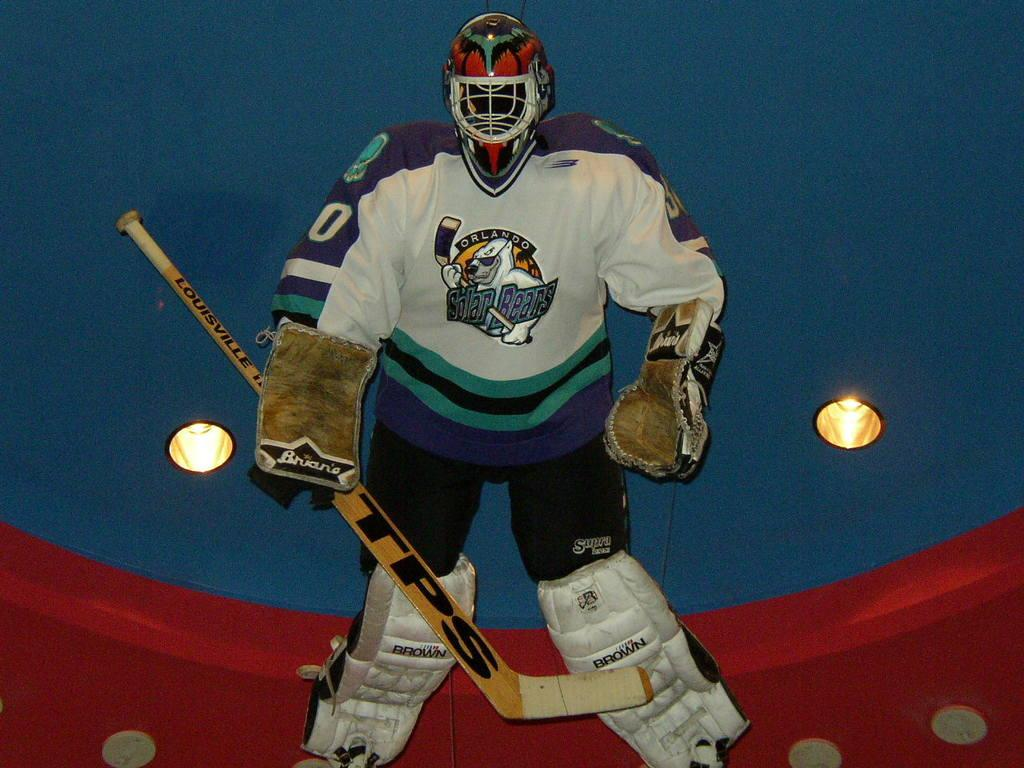What type of protective gear is present in the image? There are gloves, a helmet, and leg pads in the image. What sports equipment can be seen in the image? There is a hockey bat in the image. What type of lighting is present in the image? There are lights on the ceiling in the image. Are there any dinosaurs visible in the image? No, there are no dinosaurs present in the image. What type of polish is being applied to the hockey bat in the image? There is no polish being applied to the hockey bat in the image; it is not mentioned in the provided facts. 